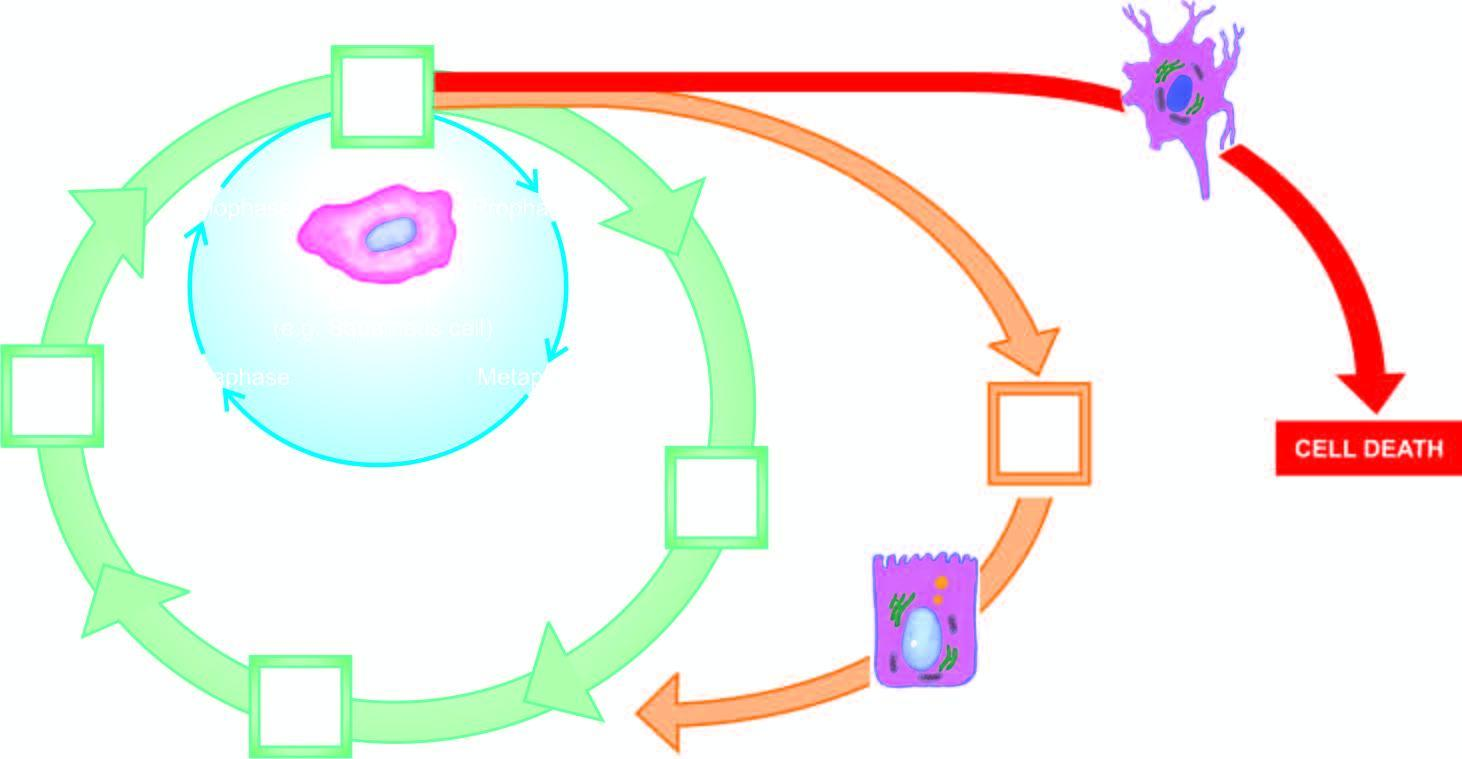does the inner circle shown with green line represent cell cycle for labile cells?
Answer the question using a single word or phrase. Yes 